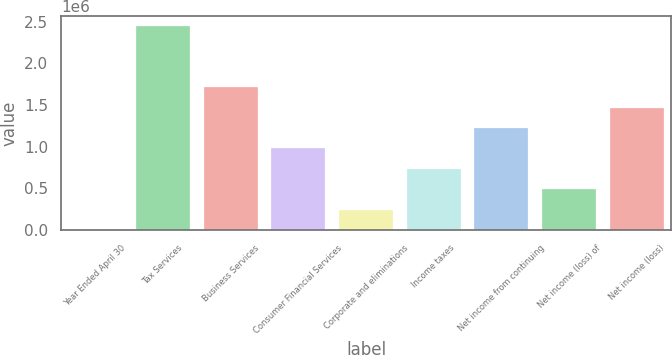Convert chart. <chart><loc_0><loc_0><loc_500><loc_500><bar_chart><fcel>Year Ended April 30<fcel>Tax Services<fcel>Business Services<fcel>Consumer Financial Services<fcel>Corporate and eliminations<fcel>Income taxes<fcel>Net income from continuing<fcel>Net income (loss) of<fcel>Net income (loss)<nl><fcel>2006<fcel>2.44975e+06<fcel>1.71543e+06<fcel>981104<fcel>246780<fcel>736330<fcel>1.22588e+06<fcel>491555<fcel>1.47065e+06<nl></chart> 